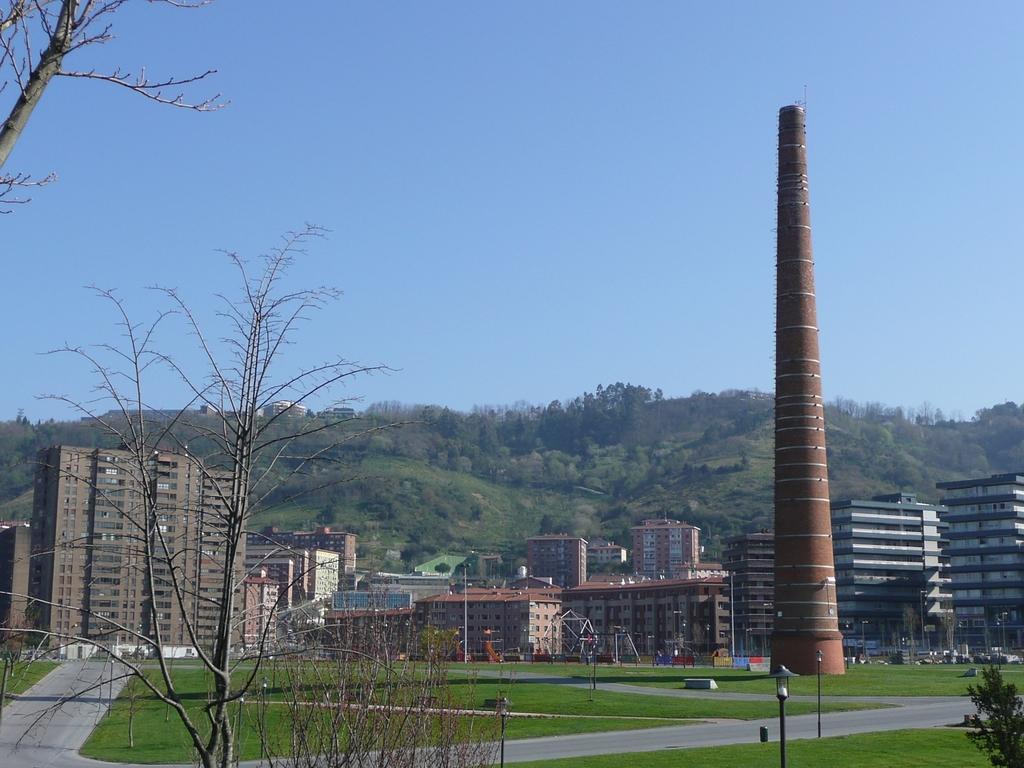How would you summarize this image in a sentence or two? Here in this picture on the right side we can see a tower present and we can also see buildings present all over there and we can see the ground is covered with grass over there and we can also see plants and trees present and behind the buildings we can see the mountains that are covered with grass, plants and trees all over there and on the ground we can see lamp posts present over there. 